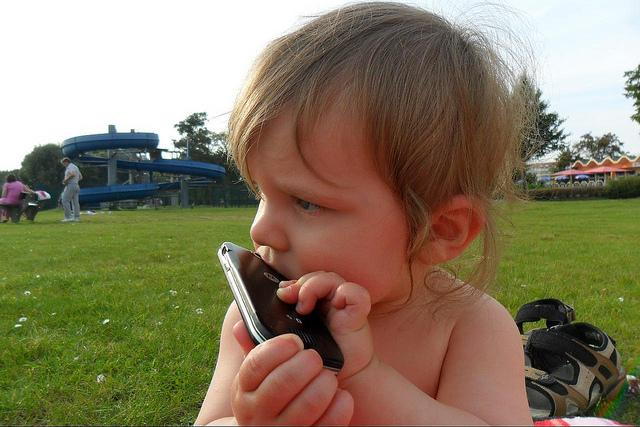What is the baby doing to the phone? Please explain your reasoning. eating. The baby is chewing on the phone. 